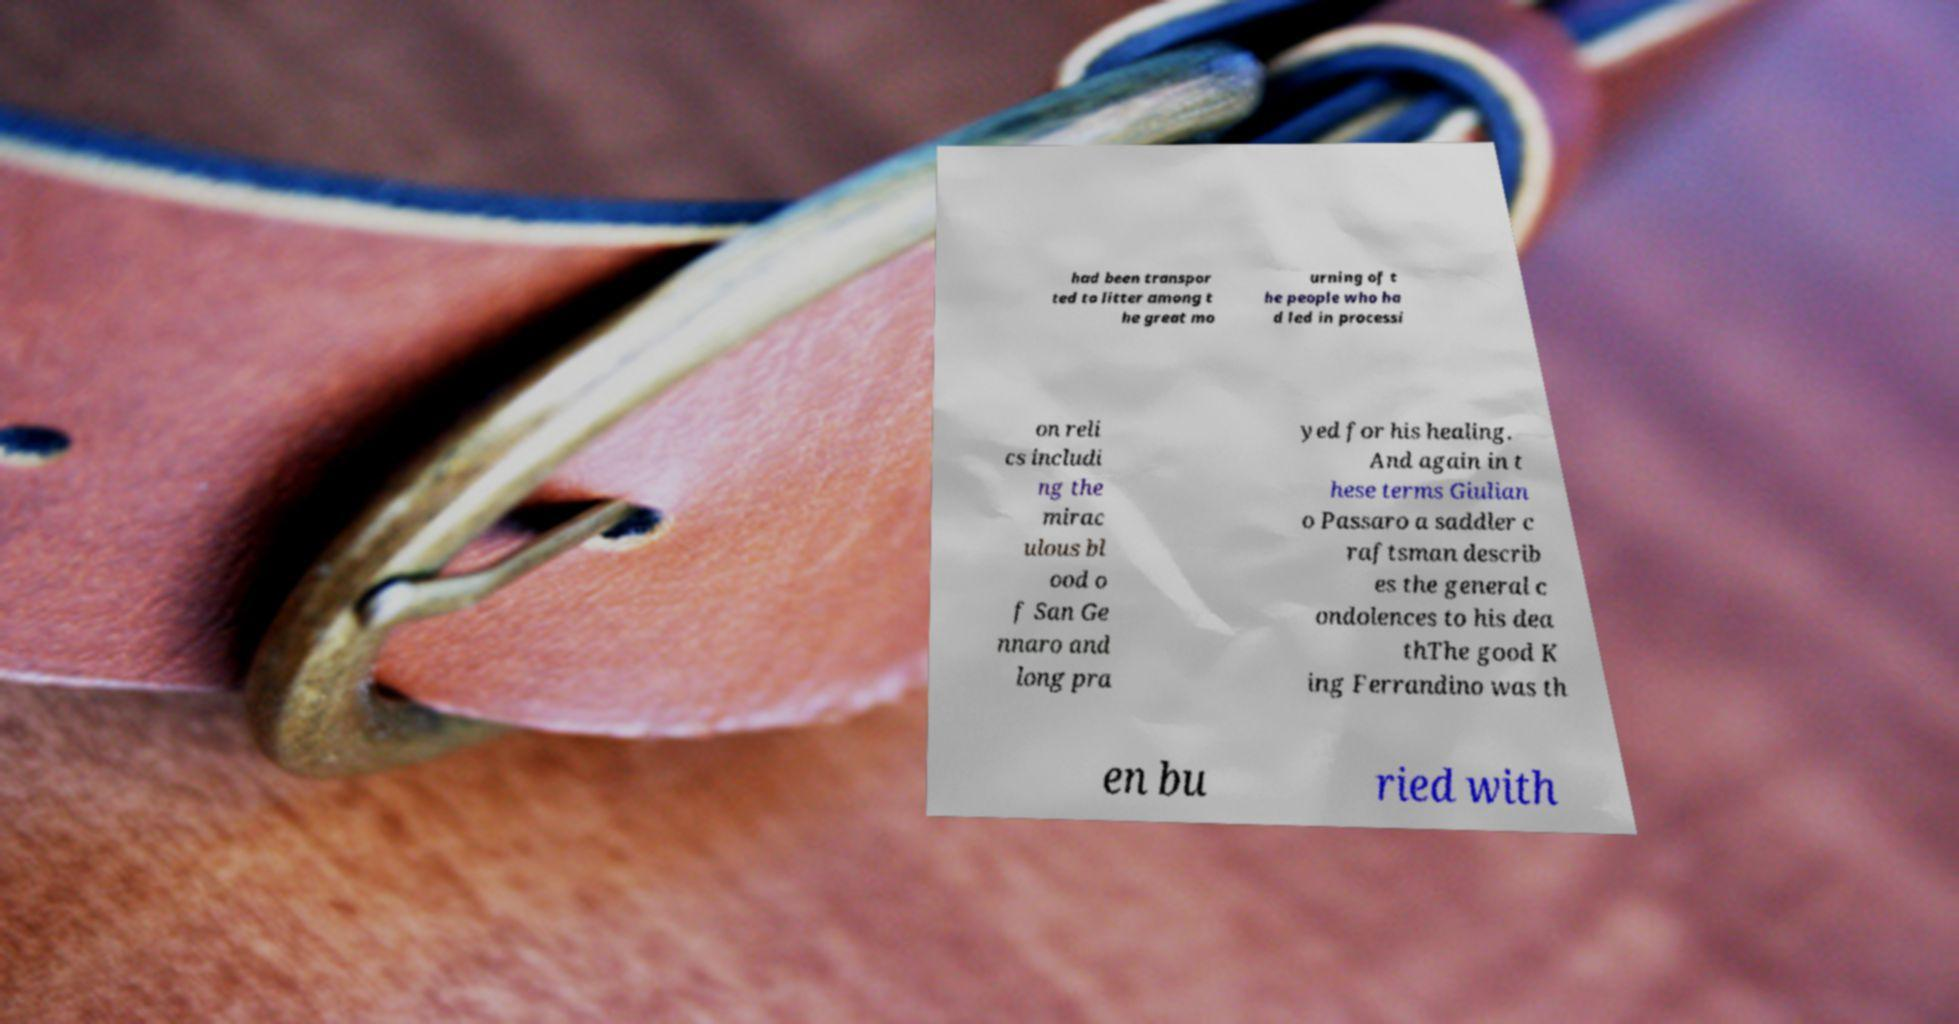For documentation purposes, I need the text within this image transcribed. Could you provide that? had been transpor ted to litter among t he great mo urning of t he people who ha d led in processi on reli cs includi ng the mirac ulous bl ood o f San Ge nnaro and long pra yed for his healing. And again in t hese terms Giulian o Passaro a saddler c raftsman describ es the general c ondolences to his dea thThe good K ing Ferrandino was th en bu ried with 